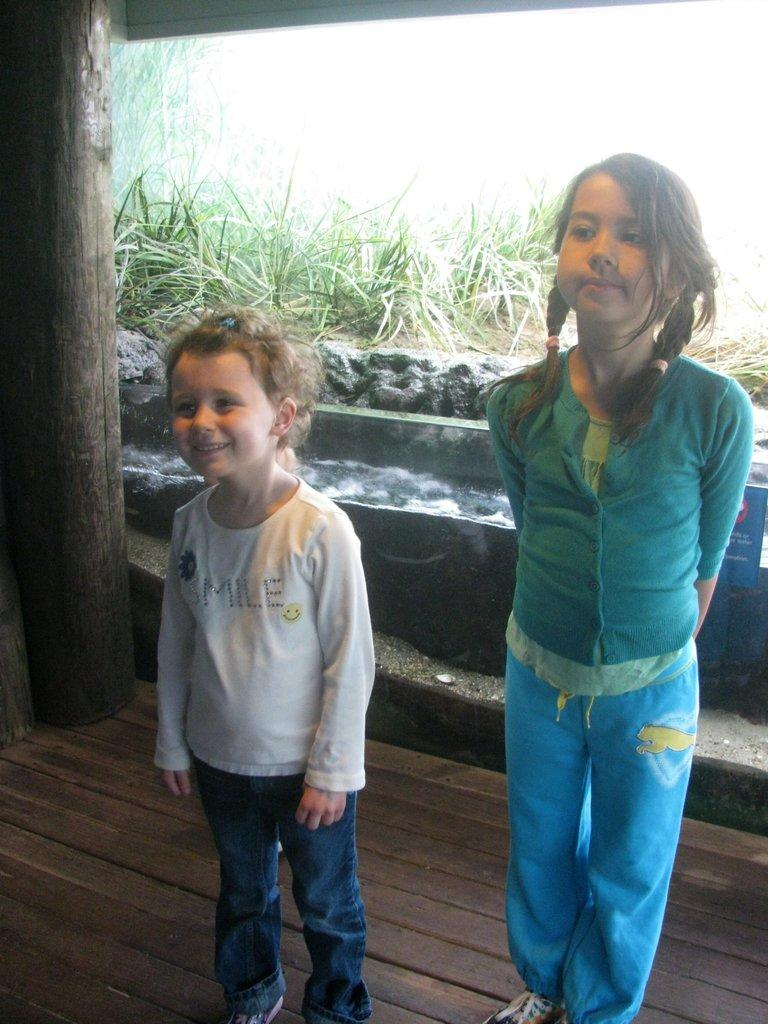What can be seen in the image? There are girls standing in the image. What is visible in the background of the image? There are plants visible in the background of the image. What type of brain is being sold at the market in the image? There is no market or brain present in the image; it features girls standing with plants in the background. 